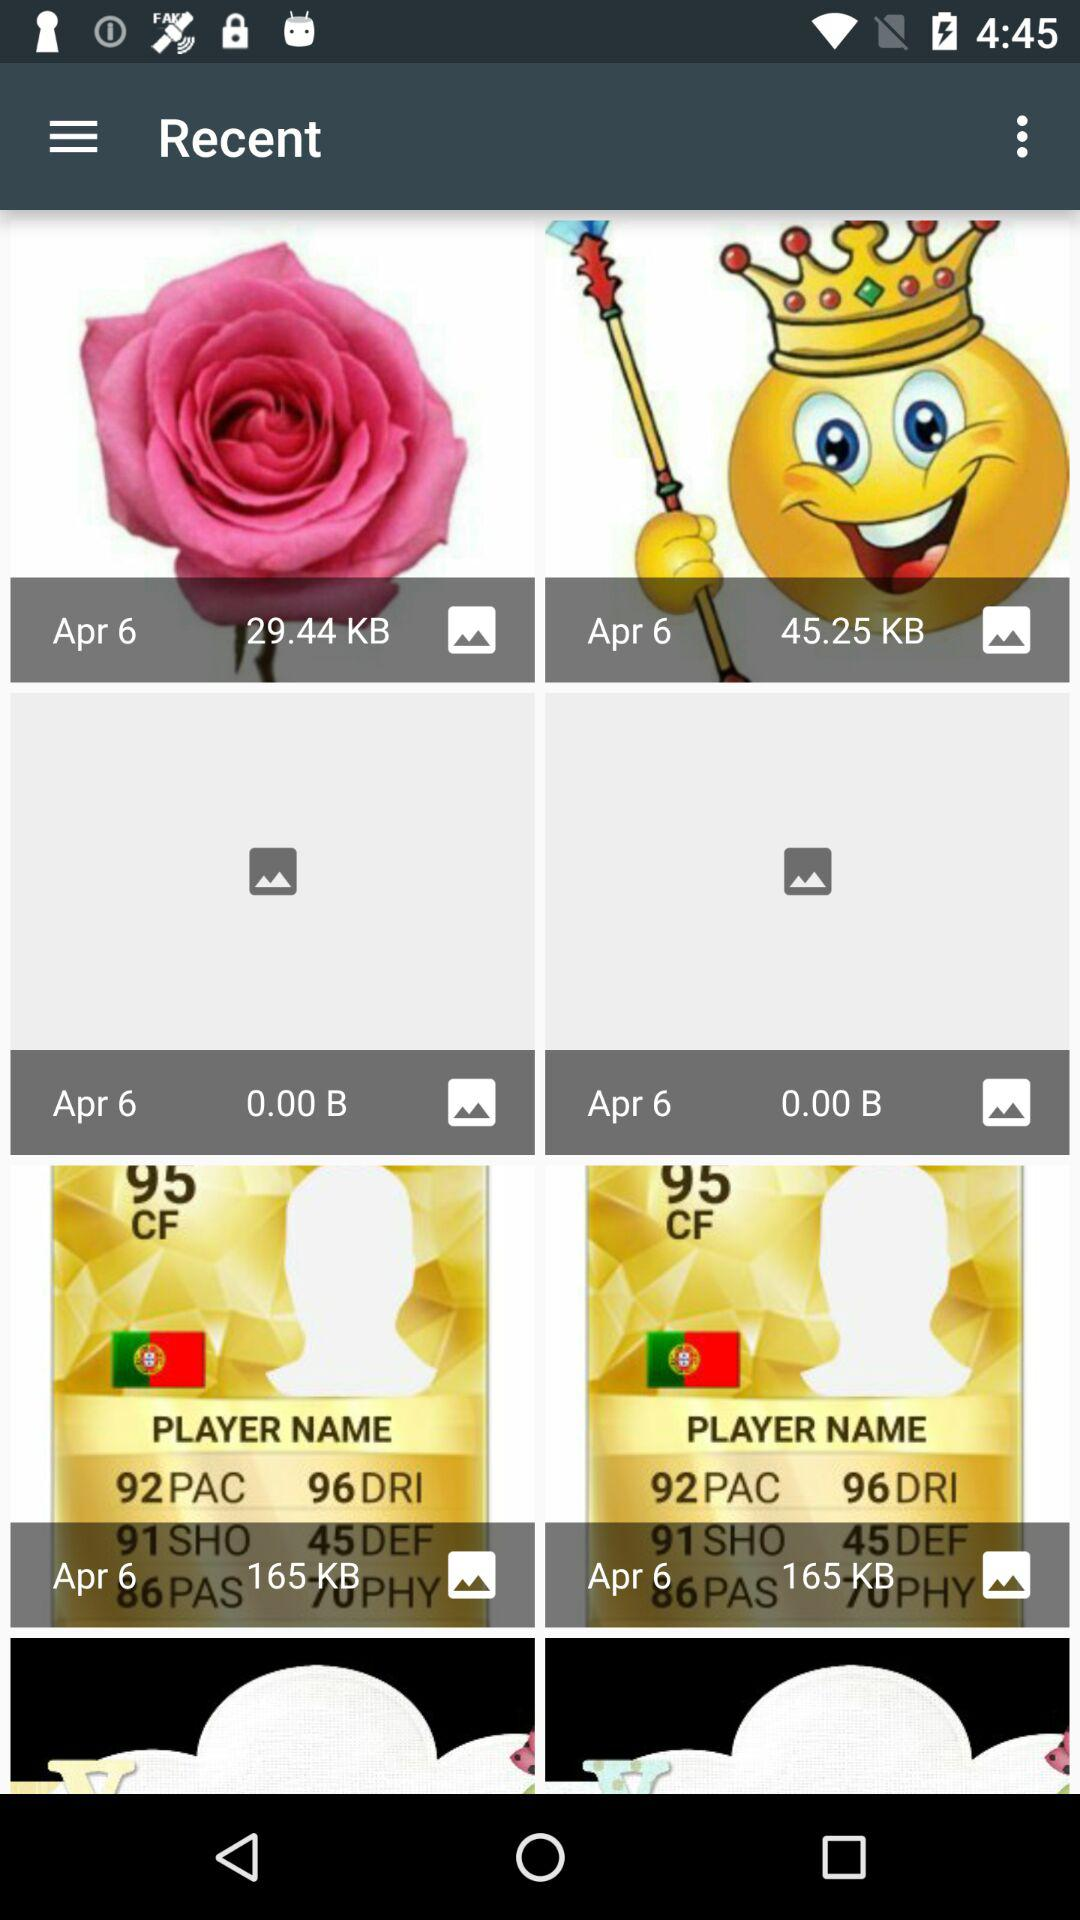What is the date? The date is April 6. 